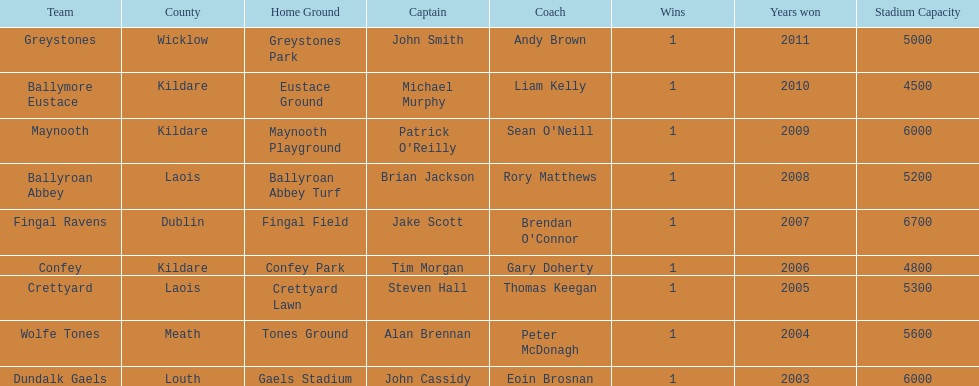Which team was the previous winner before ballyroan abbey in 2008? Fingal Ravens. 